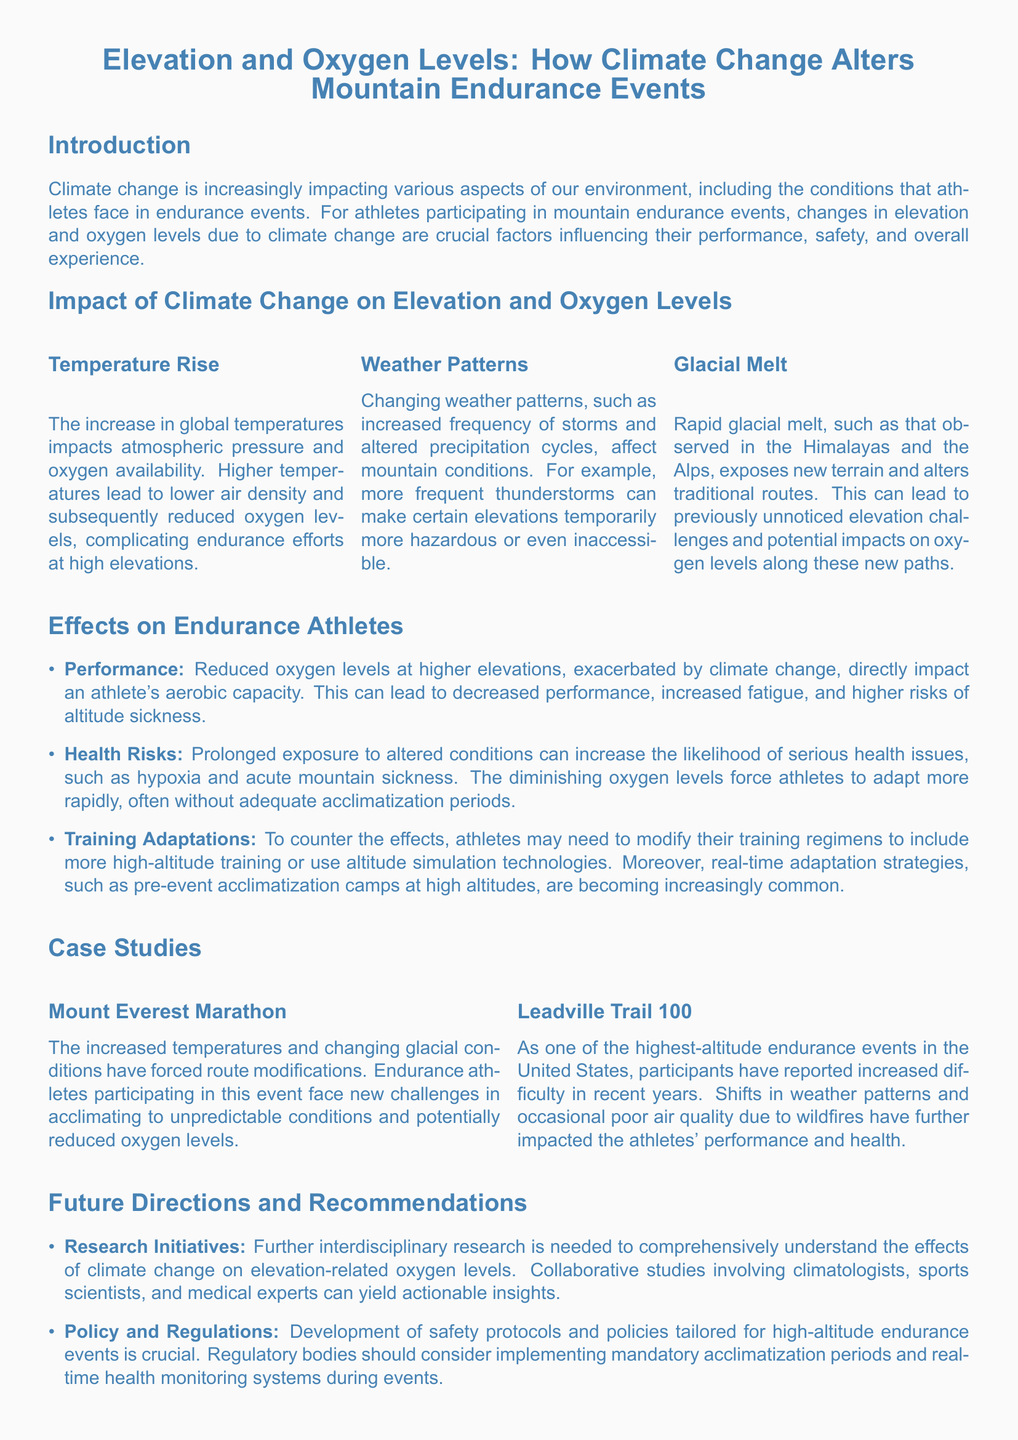What is the main focus of the whitepaper? The main focus of the whitepaper is the impact of climate change on endurance athletes, specifically regarding elevation and oxygen levels during mountain events.
Answer: Impact of climate change on endurance athletes What are two key factors influenced by climate change mentioned in the document? The document mentions temperature rise and changing weather patterns as two key factors influenced by climate change.
Answer: Temperature rise and changing weather patterns What health risk is associated with reduced oxygen levels at higher elevations? The document explicitly states that reduced oxygen levels can increase the likelihood of serious health issues such as hypoxia and acute mountain sickness.
Answer: Hypoxia What is one adaptation that athletes may need to implement? Athletes may need to modify their training regimens to include more high-altitude training or use altitude simulation technologies.
Answer: High-altitude training Which marathon is cited as a case study for the effects of climate change? The Mount Everest Marathon is cited as a case study for the effects of climate change.
Answer: Mount Everest Marathon What do the authors recommend regarding athlete education? The authors recommend educating athletes on the potential impacts of climate change on their performance and health as essential.
Answer: Educating athletes How many case studies are mentioned in the document? The document mentions two case studies regarding endurance events impacted by climate change.
Answer: Two What does the document propose for safety protocols in endurance events? The document proposes the development of safety protocols and policies tailored for high-altitude endurance events.
Answer: Safety protocols What effect does glacial melt have on traditional routes? Glacial melt exposes new terrain and alters traditional routes, leading to previously unnoticed elevation challenges.
Answer: Exposes new terrain 